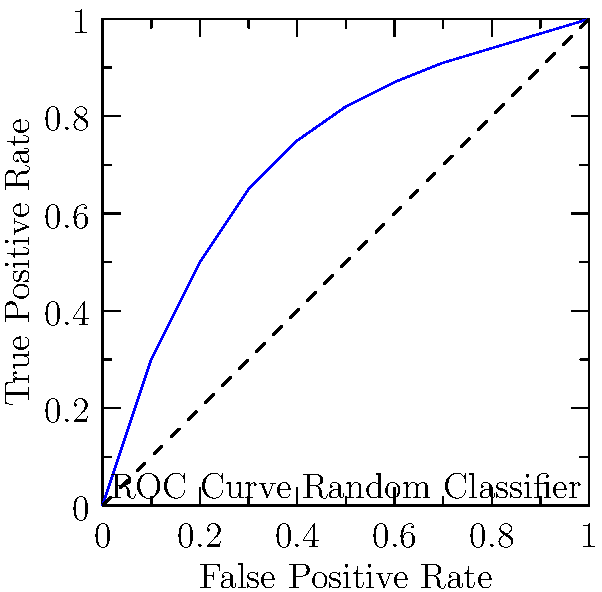As a Kaggle Grandmaster, you're evaluating a binary classification model using its ROC curve. Given the curve shown above, what can you conclude about the model's performance, and what is the approximate Area Under the Curve (AUC)? To evaluate the model's performance using the ROC curve and estimate the AUC, we'll follow these steps:

1. Interpret the ROC curve:
   - The ROC curve plots the True Positive Rate (TPR) against the False Positive Rate (FPR) at various classification thresholds.
   - A perfect classifier would have a point at (0,1), representing 100% TPR and 0% FPR.
   - The diagonal line represents a random classifier (50% accuracy).

2. Analyze the curve's position:
   - The given ROC curve is significantly above the diagonal line, indicating better performance than a random classifier.
   - The curve rises steeply at first, showing good discrimination ability at lower thresholds.

3. Estimate the AUC:
   - The AUC represents the probability that the model ranks a random positive instance higher than a random negative instance.
   - AUC ranges from 0.5 (random classifier) to 1.0 (perfect classifier).
   - Visually, the AUC is the area between the ROC curve and the x-axis.
   - By rough estimation, the area covers approximately 80-85% of the total square.

4. Interpret the AUC:
   - An AUC of 0.80-0.85 indicates good discriminative ability.
   - This suggests the model performs well in distinguishing between positive and negative classes.

5. Overall performance assessment:
   - The model shows strong predictive power, significantly outperforming a random classifier.
   - It has a good balance between TPR and FPR across various thresholds.
   - There's still room for improvement, as it doesn't reach the perfect classification point (0,1).
Answer: The model performs well with an approximate AUC of 0.80-0.85, indicating good discriminative ability. 